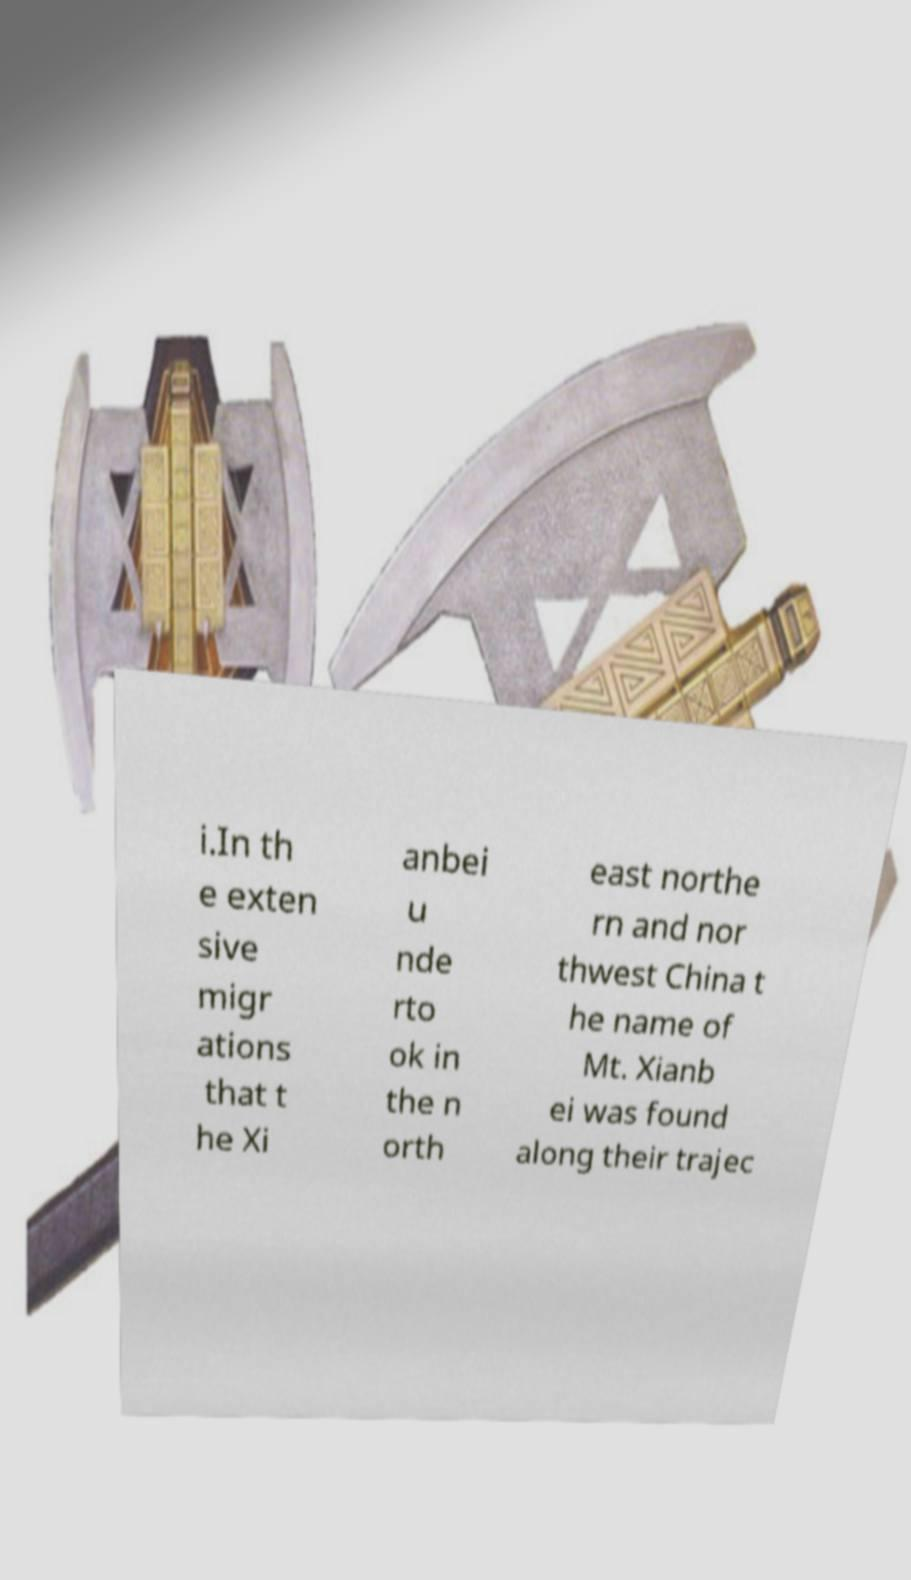Can you read and provide the text displayed in the image?This photo seems to have some interesting text. Can you extract and type it out for me? i.In th e exten sive migr ations that t he Xi anbei u nde rto ok in the n orth east northe rn and nor thwest China t he name of Mt. Xianb ei was found along their trajec 